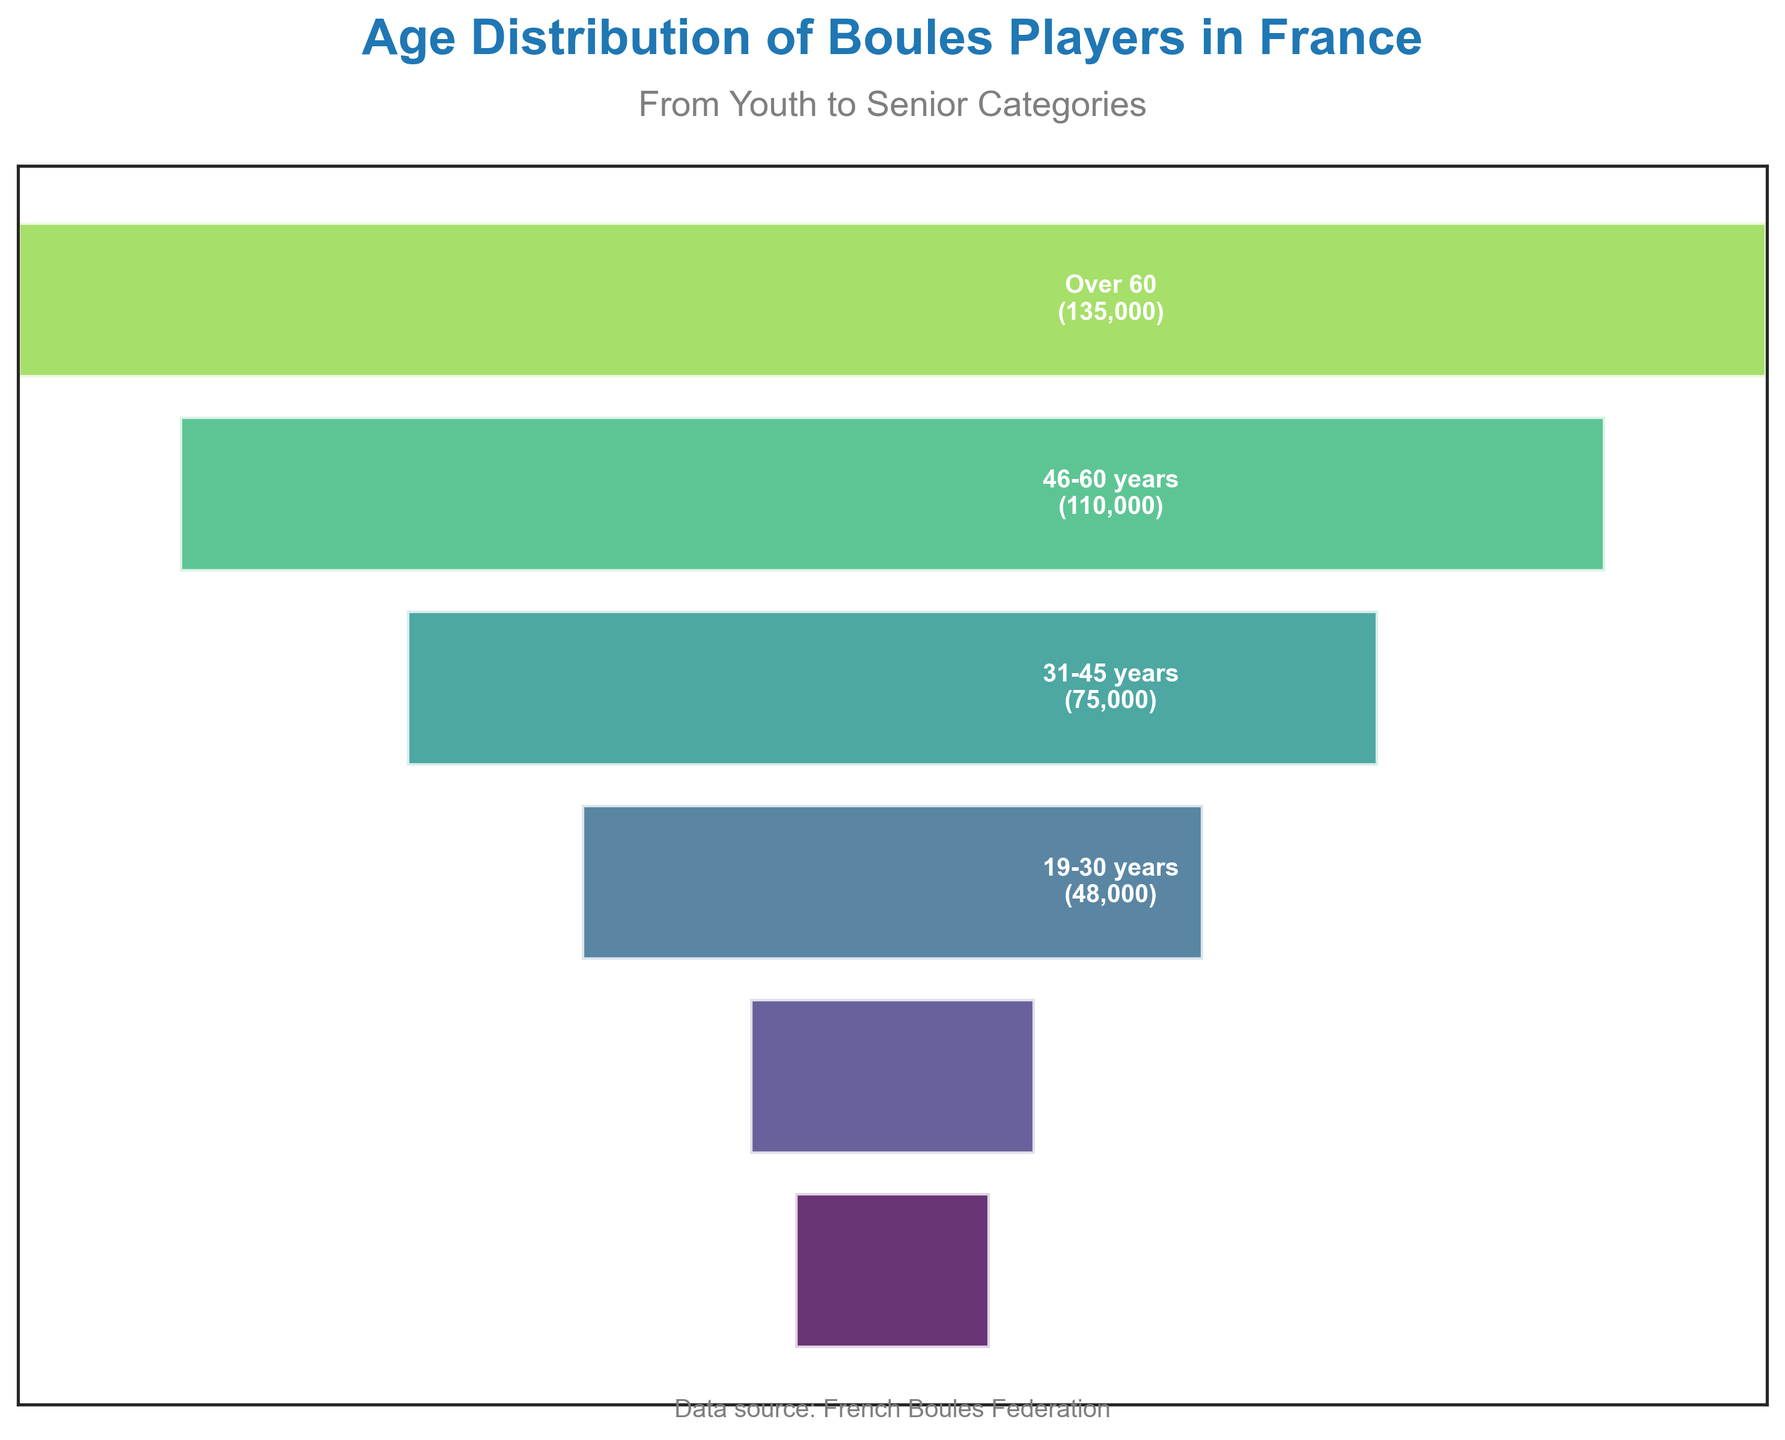what is the number of age categories presented in the chart? The chart presents different bars for each age category. Counting these bars gives the number of age categories. There are 6 age categories visible in the funnel chart.
Answer: 6 what is the title of the chart? The title of the chart is prominently displayed at the top and reads "Age Distribution of Boules Players in France".
Answer: Age Distribution of Boules Players in France How many players are there in the "19-30 years" age category? The bar labeled "19-30 years" gives the number of players in that category, which is denoted as 48,000.
Answer: 48,000 What is the difference in the number of players between the "Over 60" and "Under 12" age categories? From the figure, the "Over 60" age category has 135,000 players, and the "Under 12" has 15,000. Subtracting these gives the difference: 135,000 - 15,000 = 120,000.
Answer: 120,000 Which age category has the highest number of players? By observing the bar lengths, the "Over 60" age category has the longest bar, indicating the highest number of players, with 135,000 players.
Answer: Over 60 Are there more players in the "12-18 years" category or the "31-45 years" category? Comparing the bars, the "31-45 years" category with 75,000 players is longer than the "12-18 years" category with 22,000 players.
Answer: 31-45 years What is the average number of players in the "19-30 years" and "46-60 years" categories? The number of players in the "19-30 years" category is 48,000, and in the "46-60 years" category, it is 110,000. Their average is calculated as (48,000 + 110,000)/2 = 79,000.
Answer: 79,000 By how much does the number of players increase from the "46-60 years" category to the "Over 60" category? The number of players in the "46-60 years" category is 110,000 and in the "Over 60" category is 135,000. The increase is calculated as 135,000 - 110,000 = 25,000.
Answer: 25,000 Which age category has the smallest number of players in the funnel chart? Noting bar lengths, the "Under 12" age category has the shortest bar and thus the smallest number of players, with 15,000.
Answer: Under 12 